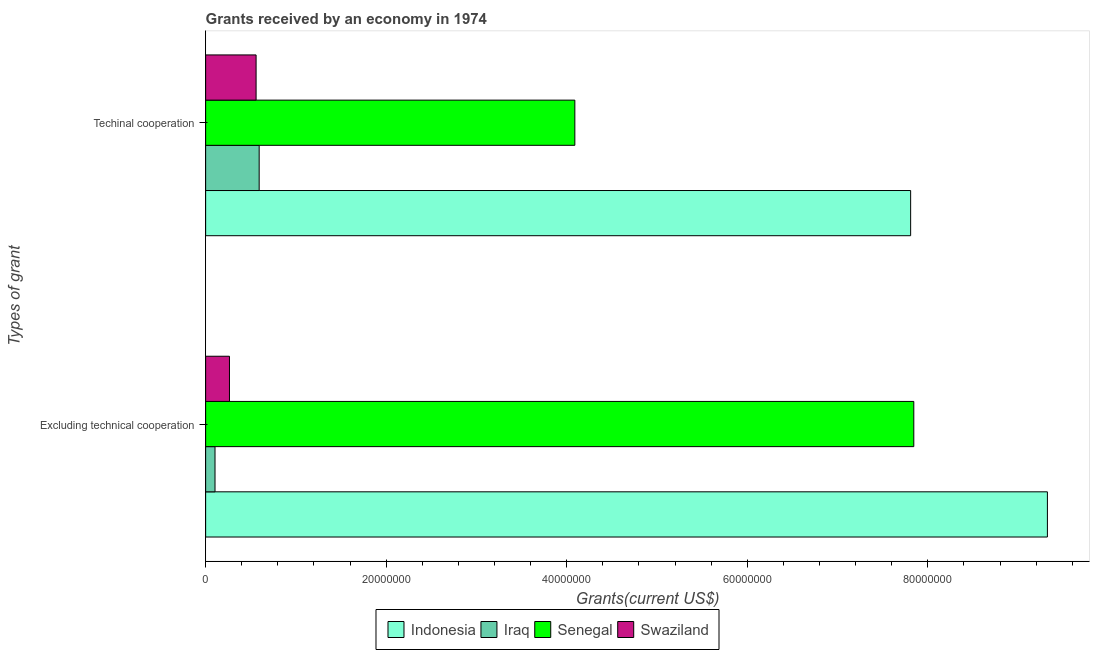How many different coloured bars are there?
Make the answer very short. 4. How many groups of bars are there?
Offer a terse response. 2. Are the number of bars on each tick of the Y-axis equal?
Your response must be concise. Yes. How many bars are there on the 2nd tick from the top?
Provide a short and direct response. 4. How many bars are there on the 2nd tick from the bottom?
Provide a short and direct response. 4. What is the label of the 2nd group of bars from the top?
Your answer should be very brief. Excluding technical cooperation. What is the amount of grants received(excluding technical cooperation) in Indonesia?
Make the answer very short. 9.32e+07. Across all countries, what is the maximum amount of grants received(excluding technical cooperation)?
Give a very brief answer. 9.32e+07. Across all countries, what is the minimum amount of grants received(including technical cooperation)?
Keep it short and to the point. 5.59e+06. In which country was the amount of grants received(excluding technical cooperation) minimum?
Give a very brief answer. Iraq. What is the total amount of grants received(excluding technical cooperation) in the graph?
Make the answer very short. 1.75e+08. What is the difference between the amount of grants received(including technical cooperation) in Swaziland and that in Senegal?
Keep it short and to the point. -3.53e+07. What is the difference between the amount of grants received(including technical cooperation) in Iraq and the amount of grants received(excluding technical cooperation) in Swaziland?
Give a very brief answer. 3.29e+06. What is the average amount of grants received(including technical cooperation) per country?
Ensure brevity in your answer.  3.26e+07. What is the difference between the amount of grants received(including technical cooperation) and amount of grants received(excluding technical cooperation) in Iraq?
Make the answer very short. 4.89e+06. In how many countries, is the amount of grants received(excluding technical cooperation) greater than 20000000 US$?
Make the answer very short. 2. What is the ratio of the amount of grants received(including technical cooperation) in Senegal to that in Swaziland?
Offer a terse response. 7.32. In how many countries, is the amount of grants received(including technical cooperation) greater than the average amount of grants received(including technical cooperation) taken over all countries?
Offer a very short reply. 2. What does the 4th bar from the top in Excluding technical cooperation represents?
Give a very brief answer. Indonesia. What does the 4th bar from the bottom in Techinal cooperation represents?
Provide a short and direct response. Swaziland. How many bars are there?
Offer a very short reply. 8. Are all the bars in the graph horizontal?
Ensure brevity in your answer.  Yes. How many countries are there in the graph?
Make the answer very short. 4. Does the graph contain any zero values?
Give a very brief answer. No. Where does the legend appear in the graph?
Provide a succinct answer. Bottom center. What is the title of the graph?
Make the answer very short. Grants received by an economy in 1974. Does "Europe(all income levels)" appear as one of the legend labels in the graph?
Offer a terse response. No. What is the label or title of the X-axis?
Your response must be concise. Grants(current US$). What is the label or title of the Y-axis?
Your response must be concise. Types of grant. What is the Grants(current US$) of Indonesia in Excluding technical cooperation?
Offer a very short reply. 9.32e+07. What is the Grants(current US$) in Iraq in Excluding technical cooperation?
Your answer should be compact. 1.04e+06. What is the Grants(current US$) in Senegal in Excluding technical cooperation?
Provide a short and direct response. 7.84e+07. What is the Grants(current US$) of Swaziland in Excluding technical cooperation?
Ensure brevity in your answer.  2.64e+06. What is the Grants(current US$) of Indonesia in Techinal cooperation?
Your answer should be compact. 7.81e+07. What is the Grants(current US$) in Iraq in Techinal cooperation?
Make the answer very short. 5.93e+06. What is the Grants(current US$) in Senegal in Techinal cooperation?
Ensure brevity in your answer.  4.09e+07. What is the Grants(current US$) of Swaziland in Techinal cooperation?
Offer a very short reply. 5.59e+06. Across all Types of grant, what is the maximum Grants(current US$) in Indonesia?
Provide a succinct answer. 9.32e+07. Across all Types of grant, what is the maximum Grants(current US$) in Iraq?
Your answer should be compact. 5.93e+06. Across all Types of grant, what is the maximum Grants(current US$) in Senegal?
Provide a short and direct response. 7.84e+07. Across all Types of grant, what is the maximum Grants(current US$) in Swaziland?
Your answer should be very brief. 5.59e+06. Across all Types of grant, what is the minimum Grants(current US$) of Indonesia?
Your response must be concise. 7.81e+07. Across all Types of grant, what is the minimum Grants(current US$) in Iraq?
Give a very brief answer. 1.04e+06. Across all Types of grant, what is the minimum Grants(current US$) in Senegal?
Keep it short and to the point. 4.09e+07. Across all Types of grant, what is the minimum Grants(current US$) of Swaziland?
Your answer should be very brief. 2.64e+06. What is the total Grants(current US$) in Indonesia in the graph?
Your answer should be very brief. 1.71e+08. What is the total Grants(current US$) of Iraq in the graph?
Make the answer very short. 6.97e+06. What is the total Grants(current US$) of Senegal in the graph?
Offer a terse response. 1.19e+08. What is the total Grants(current US$) of Swaziland in the graph?
Give a very brief answer. 8.23e+06. What is the difference between the Grants(current US$) in Indonesia in Excluding technical cooperation and that in Techinal cooperation?
Offer a very short reply. 1.52e+07. What is the difference between the Grants(current US$) of Iraq in Excluding technical cooperation and that in Techinal cooperation?
Provide a short and direct response. -4.89e+06. What is the difference between the Grants(current US$) in Senegal in Excluding technical cooperation and that in Techinal cooperation?
Your answer should be compact. 3.76e+07. What is the difference between the Grants(current US$) of Swaziland in Excluding technical cooperation and that in Techinal cooperation?
Keep it short and to the point. -2.95e+06. What is the difference between the Grants(current US$) of Indonesia in Excluding technical cooperation and the Grants(current US$) of Iraq in Techinal cooperation?
Offer a very short reply. 8.73e+07. What is the difference between the Grants(current US$) of Indonesia in Excluding technical cooperation and the Grants(current US$) of Senegal in Techinal cooperation?
Offer a terse response. 5.24e+07. What is the difference between the Grants(current US$) of Indonesia in Excluding technical cooperation and the Grants(current US$) of Swaziland in Techinal cooperation?
Provide a short and direct response. 8.77e+07. What is the difference between the Grants(current US$) of Iraq in Excluding technical cooperation and the Grants(current US$) of Senegal in Techinal cooperation?
Keep it short and to the point. -3.99e+07. What is the difference between the Grants(current US$) of Iraq in Excluding technical cooperation and the Grants(current US$) of Swaziland in Techinal cooperation?
Your answer should be very brief. -4.55e+06. What is the difference between the Grants(current US$) in Senegal in Excluding technical cooperation and the Grants(current US$) in Swaziland in Techinal cooperation?
Provide a succinct answer. 7.29e+07. What is the average Grants(current US$) in Indonesia per Types of grant?
Provide a short and direct response. 8.57e+07. What is the average Grants(current US$) in Iraq per Types of grant?
Offer a terse response. 3.48e+06. What is the average Grants(current US$) in Senegal per Types of grant?
Provide a succinct answer. 5.97e+07. What is the average Grants(current US$) of Swaziland per Types of grant?
Make the answer very short. 4.12e+06. What is the difference between the Grants(current US$) of Indonesia and Grants(current US$) of Iraq in Excluding technical cooperation?
Offer a terse response. 9.22e+07. What is the difference between the Grants(current US$) in Indonesia and Grants(current US$) in Senegal in Excluding technical cooperation?
Your answer should be very brief. 1.48e+07. What is the difference between the Grants(current US$) in Indonesia and Grants(current US$) in Swaziland in Excluding technical cooperation?
Keep it short and to the point. 9.06e+07. What is the difference between the Grants(current US$) of Iraq and Grants(current US$) of Senegal in Excluding technical cooperation?
Offer a very short reply. -7.74e+07. What is the difference between the Grants(current US$) in Iraq and Grants(current US$) in Swaziland in Excluding technical cooperation?
Provide a short and direct response. -1.60e+06. What is the difference between the Grants(current US$) of Senegal and Grants(current US$) of Swaziland in Excluding technical cooperation?
Ensure brevity in your answer.  7.58e+07. What is the difference between the Grants(current US$) of Indonesia and Grants(current US$) of Iraq in Techinal cooperation?
Offer a very short reply. 7.22e+07. What is the difference between the Grants(current US$) in Indonesia and Grants(current US$) in Senegal in Techinal cooperation?
Give a very brief answer. 3.72e+07. What is the difference between the Grants(current US$) in Indonesia and Grants(current US$) in Swaziland in Techinal cooperation?
Provide a short and direct response. 7.25e+07. What is the difference between the Grants(current US$) in Iraq and Grants(current US$) in Senegal in Techinal cooperation?
Your answer should be compact. -3.50e+07. What is the difference between the Grants(current US$) in Senegal and Grants(current US$) in Swaziland in Techinal cooperation?
Your answer should be compact. 3.53e+07. What is the ratio of the Grants(current US$) of Indonesia in Excluding technical cooperation to that in Techinal cooperation?
Offer a terse response. 1.19. What is the ratio of the Grants(current US$) of Iraq in Excluding technical cooperation to that in Techinal cooperation?
Provide a succinct answer. 0.18. What is the ratio of the Grants(current US$) in Senegal in Excluding technical cooperation to that in Techinal cooperation?
Your answer should be compact. 1.92. What is the ratio of the Grants(current US$) in Swaziland in Excluding technical cooperation to that in Techinal cooperation?
Offer a very short reply. 0.47. What is the difference between the highest and the second highest Grants(current US$) in Indonesia?
Provide a short and direct response. 1.52e+07. What is the difference between the highest and the second highest Grants(current US$) in Iraq?
Provide a short and direct response. 4.89e+06. What is the difference between the highest and the second highest Grants(current US$) of Senegal?
Your answer should be compact. 3.76e+07. What is the difference between the highest and the second highest Grants(current US$) of Swaziland?
Ensure brevity in your answer.  2.95e+06. What is the difference between the highest and the lowest Grants(current US$) in Indonesia?
Provide a succinct answer. 1.52e+07. What is the difference between the highest and the lowest Grants(current US$) in Iraq?
Offer a very short reply. 4.89e+06. What is the difference between the highest and the lowest Grants(current US$) of Senegal?
Your answer should be very brief. 3.76e+07. What is the difference between the highest and the lowest Grants(current US$) of Swaziland?
Ensure brevity in your answer.  2.95e+06. 